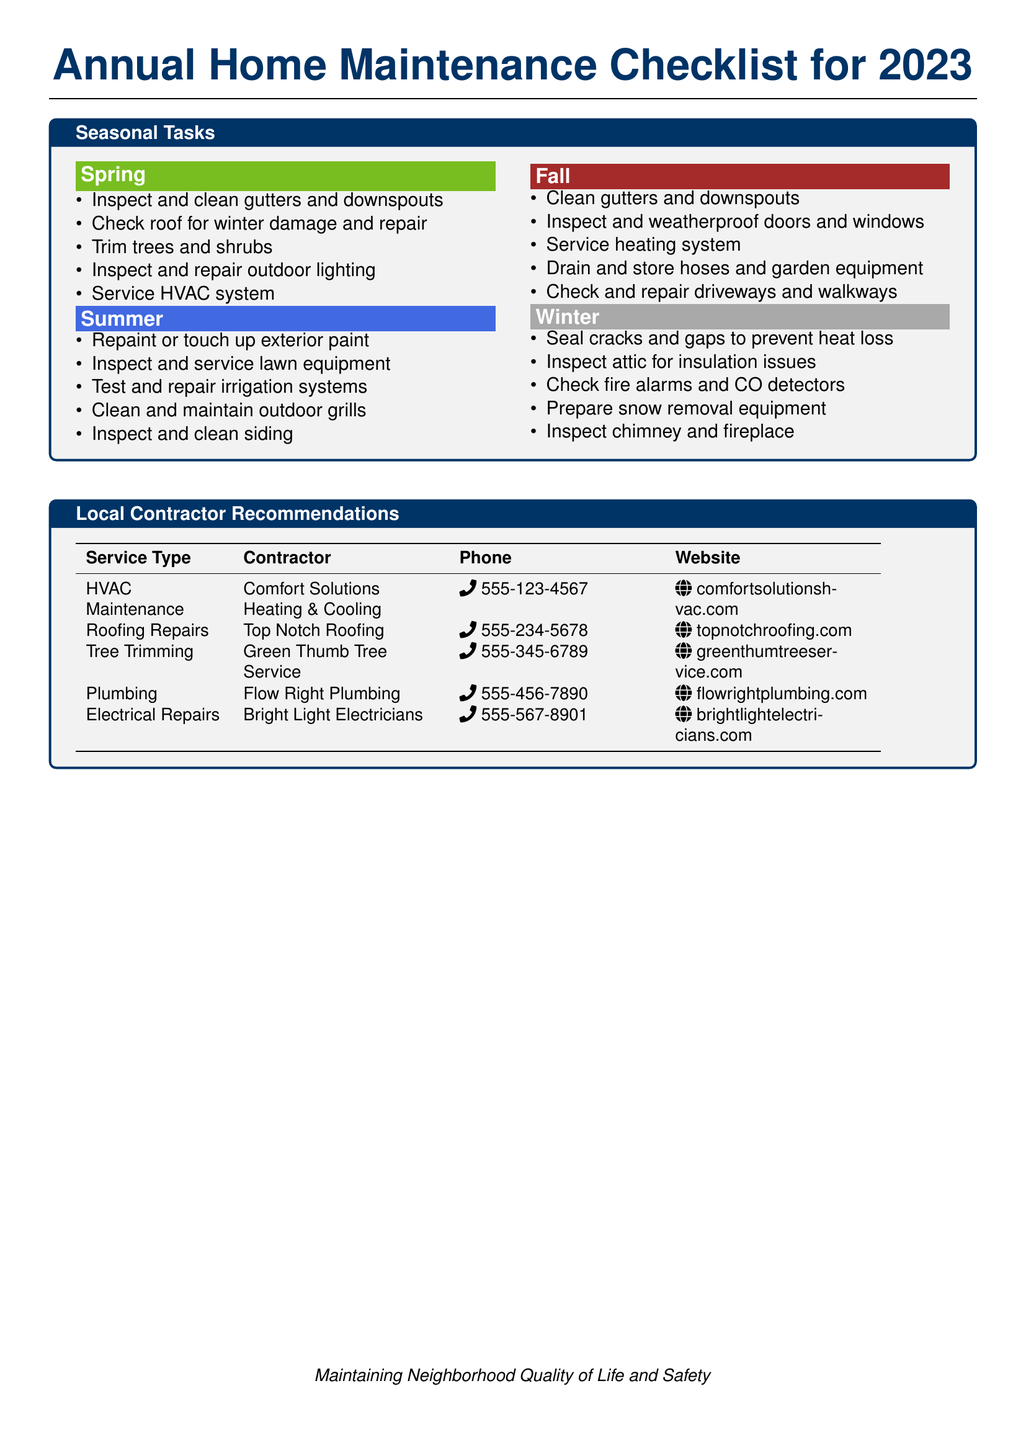What is the title of the document? The title is presented prominently at the top of the document, indicating the purpose of the content.
Answer: Annual Home Maintenance Checklist for 2023 How many seasonal tasks are listed for Spring? The Spring section contains a specific list of tasks that homeowners should complete during that season.
Answer: Five Which contractor is recommended for roofing repairs? The contractor name is included in the Local Contractor Recommendations section alongside the service type and contact details.
Answer: Top Notch Roofing What is the phone number for Flow Right Plumbing? The phone number is listed next to the contractor name in the table that provides contact information.
Answer: 555-456-7890 How many tasks are suggested for Winter maintenance? The Winter section has an enumerated list of tasks recommended for homeowners during the winter season.
Answer: Five Which season includes the task of "Inspect and weatherproof doors and windows"? This task is specified in the Fall section, identifying the seasonal focus of this maintenance activity.
Answer: Fall What is the website for Comfort Solutions Heating & Cooling? The website is provided in the Local Contractor Recommendations section and associated with the HVAC Maintenance service.
Answer: comfortsolutionshvac.com What color is associated with Fall in the document? Each season is associated with a specific color to visually distinguish them in the document.
Answer: Brown 